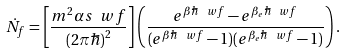<formula> <loc_0><loc_0><loc_500><loc_500>\dot { N } _ { f } = \left [ \frac { m ^ { 2 } \alpha s \ w f } { ( 2 \pi \hbar { ) } ^ { 2 } } \right ] \left ( \frac { e ^ { \beta \hbar { \ } w f } - e ^ { \beta _ { e } \hbar { \ } w f } } { ( e ^ { \beta \hbar { \ } w f } - 1 ) ( e ^ { \beta _ { e } \hbar { \ } w f } - 1 ) } \right ) .</formula> 